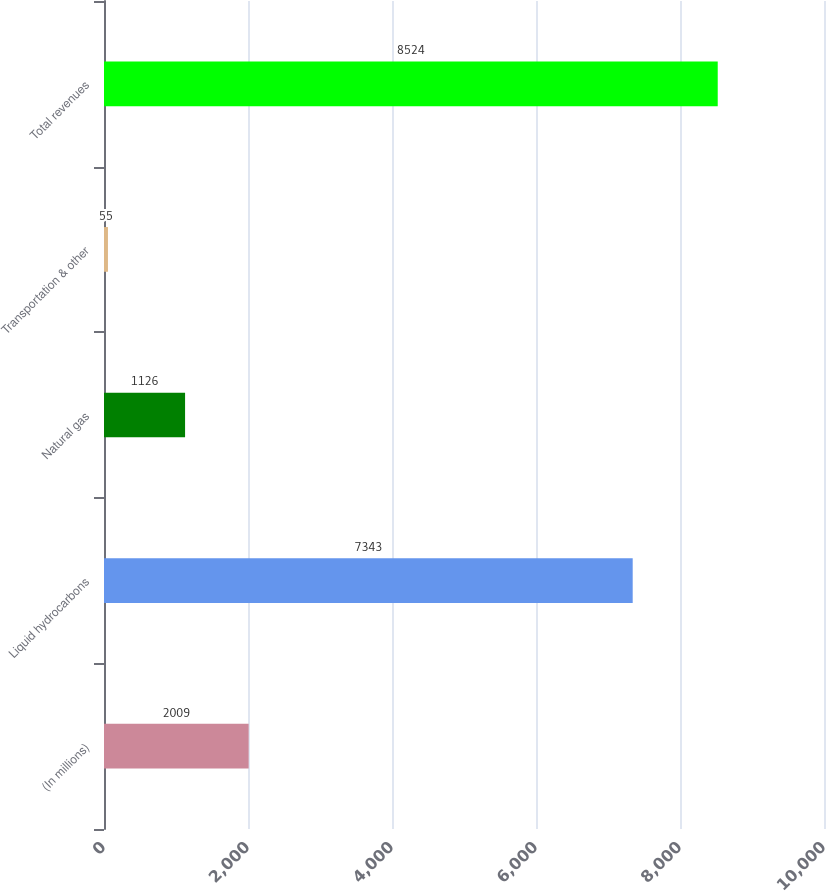Convert chart. <chart><loc_0><loc_0><loc_500><loc_500><bar_chart><fcel>(In millions)<fcel>Liquid hydrocarbons<fcel>Natural gas<fcel>Transportation & other<fcel>Total revenues<nl><fcel>2009<fcel>7343<fcel>1126<fcel>55<fcel>8524<nl></chart> 